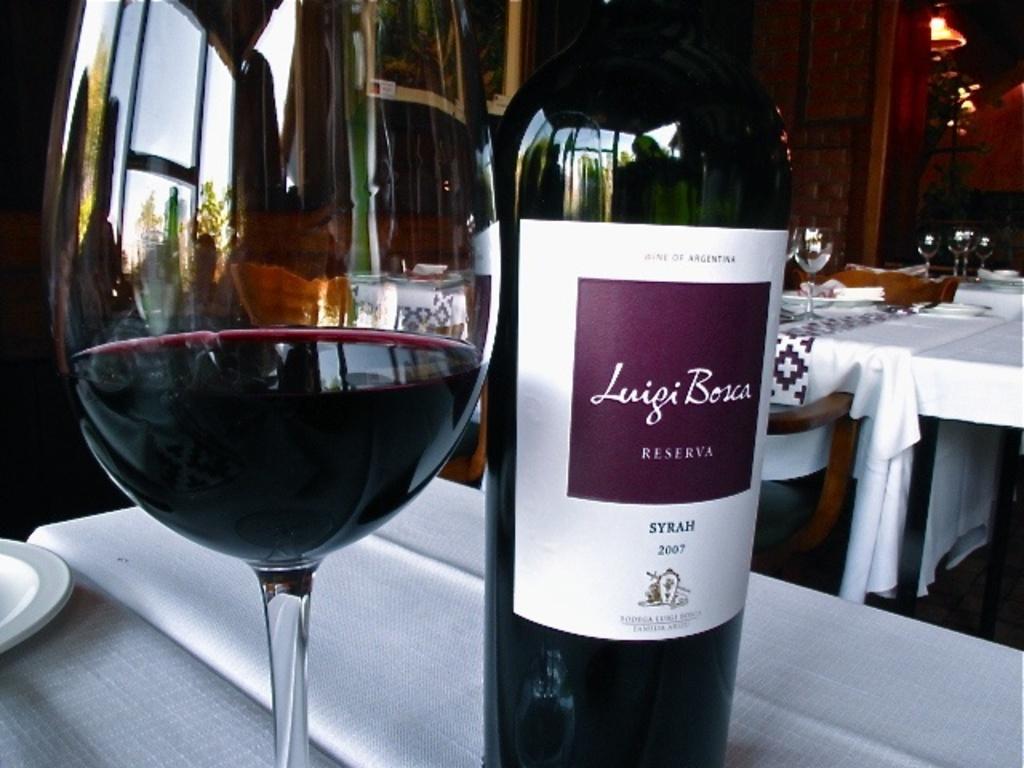What is the first name on the bottle?
Ensure brevity in your answer.  Luigi. 